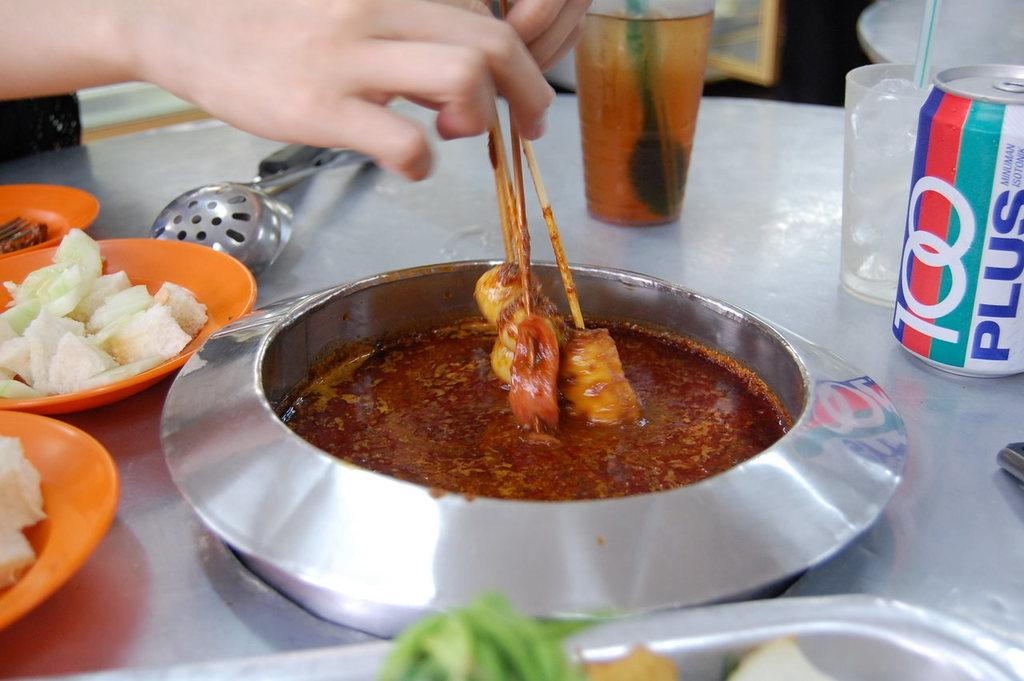What is the person in the image holding? The person is holding skewers in the image. What can be seen on the serving plates in the image? There are serving plates with food in the image. What utensils are visible in the image? Ladles are visible in the image. What type of drinking vessels are present in the image? Glass tumblers are present in the image. What type of container is used for a beverage in the image? There is a beverage tin in the image. What is the level of satisfaction the person feels while holding the skewers in the image? The provided facts do not give any information about the person's feelings or emotions, so it is impossible to determine their level of satisfaction. 